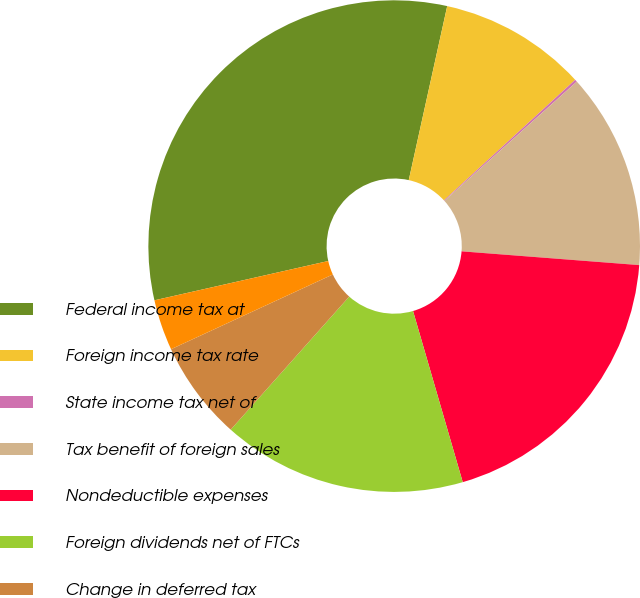<chart> <loc_0><loc_0><loc_500><loc_500><pie_chart><fcel>Federal income tax at<fcel>Foreign income tax rate<fcel>State income tax net of<fcel>Tax benefit of foreign sales<fcel>Nondeductible expenses<fcel>Foreign dividends net of FTCs<fcel>Change in deferred tax<fcel>Other<nl><fcel>32.0%<fcel>9.71%<fcel>0.16%<fcel>12.9%<fcel>19.27%<fcel>16.08%<fcel>6.53%<fcel>3.35%<nl></chart> 